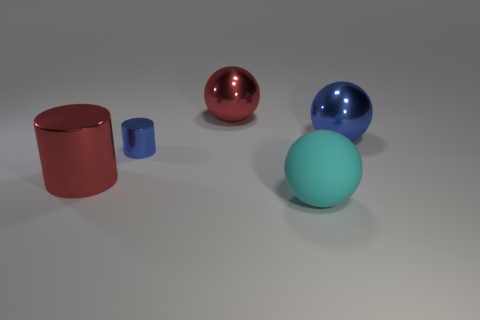Is there anything else that is the same size as the blue metallic cylinder?
Provide a succinct answer. No. Are any big yellow matte balls visible?
Your answer should be compact. No. There is a large ball in front of the red shiny thing that is in front of the red metallic object behind the big red metallic cylinder; what is its material?
Keep it short and to the point. Rubber. There is a big blue thing; is it the same shape as the red object that is to the right of the small blue cylinder?
Offer a terse response. Yes. How many other large red things are the same shape as the rubber object?
Keep it short and to the point. 1. What is the shape of the cyan matte thing?
Make the answer very short. Sphere. How big is the red object that is in front of the big metallic sphere that is on the right side of the cyan thing?
Offer a very short reply. Large. What number of things are blue metallic spheres or large yellow cubes?
Your answer should be very brief. 1. Does the rubber object have the same shape as the large blue metallic thing?
Your answer should be compact. Yes. Is there a blue sphere made of the same material as the cyan sphere?
Your answer should be compact. No. 